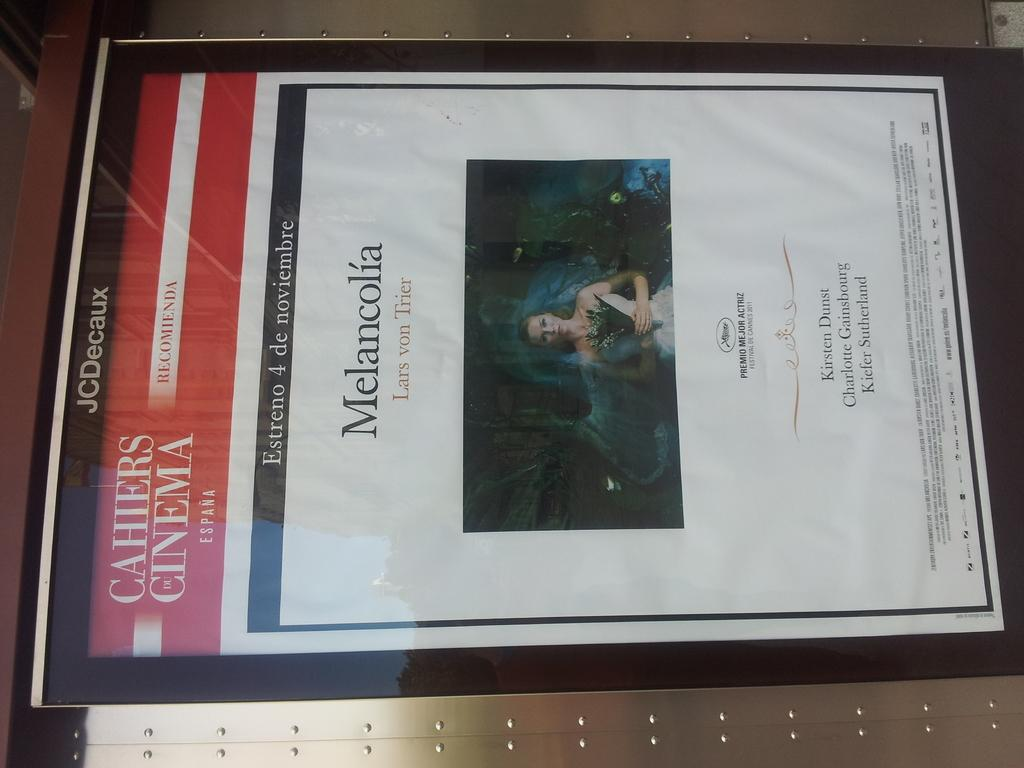Provide a one-sentence caption for the provided image. An advertisement for the Spanish cinema which reads Melancolia. 